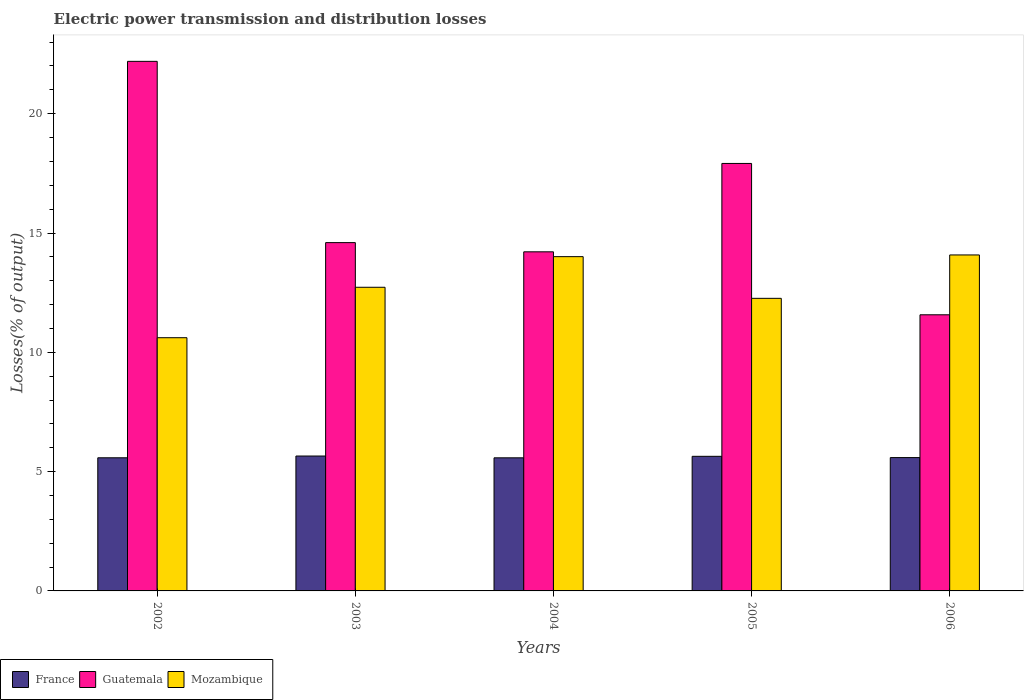How many different coloured bars are there?
Your response must be concise. 3. How many groups of bars are there?
Make the answer very short. 5. How many bars are there on the 4th tick from the right?
Provide a short and direct response. 3. What is the electric power transmission and distribution losses in Guatemala in 2002?
Ensure brevity in your answer.  22.19. Across all years, what is the maximum electric power transmission and distribution losses in Guatemala?
Your answer should be very brief. 22.19. Across all years, what is the minimum electric power transmission and distribution losses in Guatemala?
Offer a terse response. 11.57. In which year was the electric power transmission and distribution losses in France maximum?
Keep it short and to the point. 2003. In which year was the electric power transmission and distribution losses in France minimum?
Give a very brief answer. 2004. What is the total electric power transmission and distribution losses in Mozambique in the graph?
Keep it short and to the point. 63.69. What is the difference between the electric power transmission and distribution losses in Mozambique in 2003 and that in 2005?
Your answer should be very brief. 0.46. What is the difference between the electric power transmission and distribution losses in Guatemala in 2003 and the electric power transmission and distribution losses in Mozambique in 2004?
Make the answer very short. 0.59. What is the average electric power transmission and distribution losses in Mozambique per year?
Ensure brevity in your answer.  12.74. In the year 2006, what is the difference between the electric power transmission and distribution losses in Mozambique and electric power transmission and distribution losses in France?
Provide a succinct answer. 8.49. What is the ratio of the electric power transmission and distribution losses in France in 2002 to that in 2003?
Your answer should be compact. 0.99. What is the difference between the highest and the second highest electric power transmission and distribution losses in Guatemala?
Your answer should be compact. 4.28. What is the difference between the highest and the lowest electric power transmission and distribution losses in Guatemala?
Offer a very short reply. 10.62. Is the sum of the electric power transmission and distribution losses in Mozambique in 2002 and 2006 greater than the maximum electric power transmission and distribution losses in France across all years?
Your response must be concise. Yes. What does the 2nd bar from the left in 2002 represents?
Your response must be concise. Guatemala. What does the 3rd bar from the right in 2006 represents?
Give a very brief answer. France. Are all the bars in the graph horizontal?
Offer a terse response. No. What is the difference between two consecutive major ticks on the Y-axis?
Ensure brevity in your answer.  5. Are the values on the major ticks of Y-axis written in scientific E-notation?
Provide a succinct answer. No. Does the graph contain any zero values?
Keep it short and to the point. No. What is the title of the graph?
Offer a terse response. Electric power transmission and distribution losses. Does "Cayman Islands" appear as one of the legend labels in the graph?
Offer a very short reply. No. What is the label or title of the X-axis?
Offer a terse response. Years. What is the label or title of the Y-axis?
Offer a very short reply. Losses(% of output). What is the Losses(% of output) in France in 2002?
Keep it short and to the point. 5.58. What is the Losses(% of output) of Guatemala in 2002?
Provide a short and direct response. 22.19. What is the Losses(% of output) of Mozambique in 2002?
Keep it short and to the point. 10.61. What is the Losses(% of output) in France in 2003?
Ensure brevity in your answer.  5.65. What is the Losses(% of output) of Guatemala in 2003?
Offer a terse response. 14.6. What is the Losses(% of output) of Mozambique in 2003?
Your answer should be compact. 12.73. What is the Losses(% of output) in France in 2004?
Provide a succinct answer. 5.58. What is the Losses(% of output) of Guatemala in 2004?
Your answer should be compact. 14.21. What is the Losses(% of output) in Mozambique in 2004?
Give a very brief answer. 14.01. What is the Losses(% of output) of France in 2005?
Offer a terse response. 5.64. What is the Losses(% of output) of Guatemala in 2005?
Your response must be concise. 17.92. What is the Losses(% of output) in Mozambique in 2005?
Give a very brief answer. 12.26. What is the Losses(% of output) of France in 2006?
Offer a terse response. 5.59. What is the Losses(% of output) of Guatemala in 2006?
Offer a terse response. 11.57. What is the Losses(% of output) in Mozambique in 2006?
Ensure brevity in your answer.  14.08. Across all years, what is the maximum Losses(% of output) in France?
Make the answer very short. 5.65. Across all years, what is the maximum Losses(% of output) in Guatemala?
Your answer should be very brief. 22.19. Across all years, what is the maximum Losses(% of output) of Mozambique?
Ensure brevity in your answer.  14.08. Across all years, what is the minimum Losses(% of output) in France?
Offer a terse response. 5.58. Across all years, what is the minimum Losses(% of output) of Guatemala?
Offer a terse response. 11.57. Across all years, what is the minimum Losses(% of output) in Mozambique?
Keep it short and to the point. 10.61. What is the total Losses(% of output) in France in the graph?
Provide a short and direct response. 28.04. What is the total Losses(% of output) in Guatemala in the graph?
Offer a very short reply. 80.49. What is the total Losses(% of output) in Mozambique in the graph?
Your answer should be very brief. 63.69. What is the difference between the Losses(% of output) in France in 2002 and that in 2003?
Offer a very short reply. -0.07. What is the difference between the Losses(% of output) of Guatemala in 2002 and that in 2003?
Your response must be concise. 7.6. What is the difference between the Losses(% of output) of Mozambique in 2002 and that in 2003?
Provide a succinct answer. -2.11. What is the difference between the Losses(% of output) in France in 2002 and that in 2004?
Offer a terse response. 0. What is the difference between the Losses(% of output) in Guatemala in 2002 and that in 2004?
Make the answer very short. 7.98. What is the difference between the Losses(% of output) of Mozambique in 2002 and that in 2004?
Provide a short and direct response. -3.4. What is the difference between the Losses(% of output) in France in 2002 and that in 2005?
Provide a short and direct response. -0.06. What is the difference between the Losses(% of output) in Guatemala in 2002 and that in 2005?
Your answer should be compact. 4.28. What is the difference between the Losses(% of output) of Mozambique in 2002 and that in 2005?
Make the answer very short. -1.65. What is the difference between the Losses(% of output) in France in 2002 and that in 2006?
Ensure brevity in your answer.  -0.01. What is the difference between the Losses(% of output) in Guatemala in 2002 and that in 2006?
Keep it short and to the point. 10.62. What is the difference between the Losses(% of output) of Mozambique in 2002 and that in 2006?
Provide a short and direct response. -3.47. What is the difference between the Losses(% of output) of France in 2003 and that in 2004?
Provide a short and direct response. 0.08. What is the difference between the Losses(% of output) in Guatemala in 2003 and that in 2004?
Your response must be concise. 0.39. What is the difference between the Losses(% of output) in Mozambique in 2003 and that in 2004?
Your answer should be compact. -1.28. What is the difference between the Losses(% of output) in France in 2003 and that in 2005?
Provide a short and direct response. 0.01. What is the difference between the Losses(% of output) in Guatemala in 2003 and that in 2005?
Ensure brevity in your answer.  -3.32. What is the difference between the Losses(% of output) of Mozambique in 2003 and that in 2005?
Offer a very short reply. 0.46. What is the difference between the Losses(% of output) in France in 2003 and that in 2006?
Offer a very short reply. 0.07. What is the difference between the Losses(% of output) of Guatemala in 2003 and that in 2006?
Ensure brevity in your answer.  3.02. What is the difference between the Losses(% of output) of Mozambique in 2003 and that in 2006?
Your answer should be compact. -1.35. What is the difference between the Losses(% of output) in France in 2004 and that in 2005?
Provide a short and direct response. -0.06. What is the difference between the Losses(% of output) in Guatemala in 2004 and that in 2005?
Offer a terse response. -3.7. What is the difference between the Losses(% of output) of Mozambique in 2004 and that in 2005?
Make the answer very short. 1.75. What is the difference between the Losses(% of output) of France in 2004 and that in 2006?
Provide a short and direct response. -0.01. What is the difference between the Losses(% of output) of Guatemala in 2004 and that in 2006?
Your answer should be compact. 2.64. What is the difference between the Losses(% of output) in Mozambique in 2004 and that in 2006?
Make the answer very short. -0.07. What is the difference between the Losses(% of output) in France in 2005 and that in 2006?
Your answer should be compact. 0.05. What is the difference between the Losses(% of output) in Guatemala in 2005 and that in 2006?
Give a very brief answer. 6.34. What is the difference between the Losses(% of output) in Mozambique in 2005 and that in 2006?
Your answer should be very brief. -1.82. What is the difference between the Losses(% of output) in France in 2002 and the Losses(% of output) in Guatemala in 2003?
Provide a succinct answer. -9.02. What is the difference between the Losses(% of output) of France in 2002 and the Losses(% of output) of Mozambique in 2003?
Ensure brevity in your answer.  -7.15. What is the difference between the Losses(% of output) of Guatemala in 2002 and the Losses(% of output) of Mozambique in 2003?
Provide a succinct answer. 9.47. What is the difference between the Losses(% of output) of France in 2002 and the Losses(% of output) of Guatemala in 2004?
Provide a succinct answer. -8.63. What is the difference between the Losses(% of output) in France in 2002 and the Losses(% of output) in Mozambique in 2004?
Offer a very short reply. -8.43. What is the difference between the Losses(% of output) in Guatemala in 2002 and the Losses(% of output) in Mozambique in 2004?
Your answer should be very brief. 8.18. What is the difference between the Losses(% of output) of France in 2002 and the Losses(% of output) of Guatemala in 2005?
Offer a terse response. -12.34. What is the difference between the Losses(% of output) in France in 2002 and the Losses(% of output) in Mozambique in 2005?
Make the answer very short. -6.68. What is the difference between the Losses(% of output) of Guatemala in 2002 and the Losses(% of output) of Mozambique in 2005?
Offer a very short reply. 9.93. What is the difference between the Losses(% of output) in France in 2002 and the Losses(% of output) in Guatemala in 2006?
Provide a succinct answer. -5.99. What is the difference between the Losses(% of output) of France in 2002 and the Losses(% of output) of Mozambique in 2006?
Offer a terse response. -8.5. What is the difference between the Losses(% of output) in Guatemala in 2002 and the Losses(% of output) in Mozambique in 2006?
Offer a terse response. 8.11. What is the difference between the Losses(% of output) of France in 2003 and the Losses(% of output) of Guatemala in 2004?
Give a very brief answer. -8.56. What is the difference between the Losses(% of output) in France in 2003 and the Losses(% of output) in Mozambique in 2004?
Make the answer very short. -8.36. What is the difference between the Losses(% of output) of Guatemala in 2003 and the Losses(% of output) of Mozambique in 2004?
Give a very brief answer. 0.59. What is the difference between the Losses(% of output) of France in 2003 and the Losses(% of output) of Guatemala in 2005?
Ensure brevity in your answer.  -12.26. What is the difference between the Losses(% of output) in France in 2003 and the Losses(% of output) in Mozambique in 2005?
Give a very brief answer. -6.61. What is the difference between the Losses(% of output) of Guatemala in 2003 and the Losses(% of output) of Mozambique in 2005?
Offer a terse response. 2.34. What is the difference between the Losses(% of output) in France in 2003 and the Losses(% of output) in Guatemala in 2006?
Keep it short and to the point. -5.92. What is the difference between the Losses(% of output) in France in 2003 and the Losses(% of output) in Mozambique in 2006?
Ensure brevity in your answer.  -8.43. What is the difference between the Losses(% of output) of Guatemala in 2003 and the Losses(% of output) of Mozambique in 2006?
Ensure brevity in your answer.  0.52. What is the difference between the Losses(% of output) in France in 2004 and the Losses(% of output) in Guatemala in 2005?
Your answer should be compact. -12.34. What is the difference between the Losses(% of output) of France in 2004 and the Losses(% of output) of Mozambique in 2005?
Make the answer very short. -6.68. What is the difference between the Losses(% of output) of Guatemala in 2004 and the Losses(% of output) of Mozambique in 2005?
Provide a succinct answer. 1.95. What is the difference between the Losses(% of output) in France in 2004 and the Losses(% of output) in Guatemala in 2006?
Offer a terse response. -5.99. What is the difference between the Losses(% of output) in France in 2004 and the Losses(% of output) in Mozambique in 2006?
Give a very brief answer. -8.5. What is the difference between the Losses(% of output) in Guatemala in 2004 and the Losses(% of output) in Mozambique in 2006?
Keep it short and to the point. 0.13. What is the difference between the Losses(% of output) of France in 2005 and the Losses(% of output) of Guatemala in 2006?
Provide a succinct answer. -5.93. What is the difference between the Losses(% of output) of France in 2005 and the Losses(% of output) of Mozambique in 2006?
Offer a very short reply. -8.44. What is the difference between the Losses(% of output) in Guatemala in 2005 and the Losses(% of output) in Mozambique in 2006?
Provide a succinct answer. 3.84. What is the average Losses(% of output) of France per year?
Your answer should be very brief. 5.61. What is the average Losses(% of output) in Guatemala per year?
Your answer should be compact. 16.1. What is the average Losses(% of output) in Mozambique per year?
Your response must be concise. 12.74. In the year 2002, what is the difference between the Losses(% of output) in France and Losses(% of output) in Guatemala?
Make the answer very short. -16.61. In the year 2002, what is the difference between the Losses(% of output) in France and Losses(% of output) in Mozambique?
Provide a succinct answer. -5.03. In the year 2002, what is the difference between the Losses(% of output) in Guatemala and Losses(% of output) in Mozambique?
Provide a succinct answer. 11.58. In the year 2003, what is the difference between the Losses(% of output) in France and Losses(% of output) in Guatemala?
Ensure brevity in your answer.  -8.94. In the year 2003, what is the difference between the Losses(% of output) of France and Losses(% of output) of Mozambique?
Keep it short and to the point. -7.07. In the year 2003, what is the difference between the Losses(% of output) of Guatemala and Losses(% of output) of Mozambique?
Ensure brevity in your answer.  1.87. In the year 2004, what is the difference between the Losses(% of output) in France and Losses(% of output) in Guatemala?
Give a very brief answer. -8.63. In the year 2004, what is the difference between the Losses(% of output) in France and Losses(% of output) in Mozambique?
Your response must be concise. -8.43. In the year 2004, what is the difference between the Losses(% of output) in Guatemala and Losses(% of output) in Mozambique?
Provide a succinct answer. 0.2. In the year 2005, what is the difference between the Losses(% of output) in France and Losses(% of output) in Guatemala?
Keep it short and to the point. -12.27. In the year 2005, what is the difference between the Losses(% of output) in France and Losses(% of output) in Mozambique?
Offer a very short reply. -6.62. In the year 2005, what is the difference between the Losses(% of output) in Guatemala and Losses(% of output) in Mozambique?
Your answer should be very brief. 5.65. In the year 2006, what is the difference between the Losses(% of output) of France and Losses(% of output) of Guatemala?
Make the answer very short. -5.98. In the year 2006, what is the difference between the Losses(% of output) in France and Losses(% of output) in Mozambique?
Ensure brevity in your answer.  -8.49. In the year 2006, what is the difference between the Losses(% of output) of Guatemala and Losses(% of output) of Mozambique?
Your response must be concise. -2.51. What is the ratio of the Losses(% of output) in France in 2002 to that in 2003?
Offer a very short reply. 0.99. What is the ratio of the Losses(% of output) of Guatemala in 2002 to that in 2003?
Give a very brief answer. 1.52. What is the ratio of the Losses(% of output) in Mozambique in 2002 to that in 2003?
Make the answer very short. 0.83. What is the ratio of the Losses(% of output) in Guatemala in 2002 to that in 2004?
Ensure brevity in your answer.  1.56. What is the ratio of the Losses(% of output) of Mozambique in 2002 to that in 2004?
Make the answer very short. 0.76. What is the ratio of the Losses(% of output) in France in 2002 to that in 2005?
Your response must be concise. 0.99. What is the ratio of the Losses(% of output) of Guatemala in 2002 to that in 2005?
Your response must be concise. 1.24. What is the ratio of the Losses(% of output) of Mozambique in 2002 to that in 2005?
Provide a short and direct response. 0.87. What is the ratio of the Losses(% of output) in France in 2002 to that in 2006?
Your answer should be very brief. 1. What is the ratio of the Losses(% of output) in Guatemala in 2002 to that in 2006?
Make the answer very short. 1.92. What is the ratio of the Losses(% of output) of Mozambique in 2002 to that in 2006?
Your response must be concise. 0.75. What is the ratio of the Losses(% of output) of France in 2003 to that in 2004?
Give a very brief answer. 1.01. What is the ratio of the Losses(% of output) in Guatemala in 2003 to that in 2004?
Provide a succinct answer. 1.03. What is the ratio of the Losses(% of output) of Mozambique in 2003 to that in 2004?
Your answer should be compact. 0.91. What is the ratio of the Losses(% of output) in Guatemala in 2003 to that in 2005?
Keep it short and to the point. 0.81. What is the ratio of the Losses(% of output) in Mozambique in 2003 to that in 2005?
Offer a terse response. 1.04. What is the ratio of the Losses(% of output) in France in 2003 to that in 2006?
Offer a very short reply. 1.01. What is the ratio of the Losses(% of output) of Guatemala in 2003 to that in 2006?
Ensure brevity in your answer.  1.26. What is the ratio of the Losses(% of output) in Mozambique in 2003 to that in 2006?
Make the answer very short. 0.9. What is the ratio of the Losses(% of output) of Guatemala in 2004 to that in 2005?
Provide a succinct answer. 0.79. What is the ratio of the Losses(% of output) of Mozambique in 2004 to that in 2005?
Give a very brief answer. 1.14. What is the ratio of the Losses(% of output) of France in 2004 to that in 2006?
Your response must be concise. 1. What is the ratio of the Losses(% of output) of Guatemala in 2004 to that in 2006?
Provide a short and direct response. 1.23. What is the ratio of the Losses(% of output) of France in 2005 to that in 2006?
Ensure brevity in your answer.  1.01. What is the ratio of the Losses(% of output) of Guatemala in 2005 to that in 2006?
Keep it short and to the point. 1.55. What is the ratio of the Losses(% of output) in Mozambique in 2005 to that in 2006?
Offer a very short reply. 0.87. What is the difference between the highest and the second highest Losses(% of output) in France?
Provide a succinct answer. 0.01. What is the difference between the highest and the second highest Losses(% of output) of Guatemala?
Offer a very short reply. 4.28. What is the difference between the highest and the second highest Losses(% of output) in Mozambique?
Provide a succinct answer. 0.07. What is the difference between the highest and the lowest Losses(% of output) in France?
Provide a succinct answer. 0.08. What is the difference between the highest and the lowest Losses(% of output) in Guatemala?
Keep it short and to the point. 10.62. What is the difference between the highest and the lowest Losses(% of output) of Mozambique?
Your response must be concise. 3.47. 